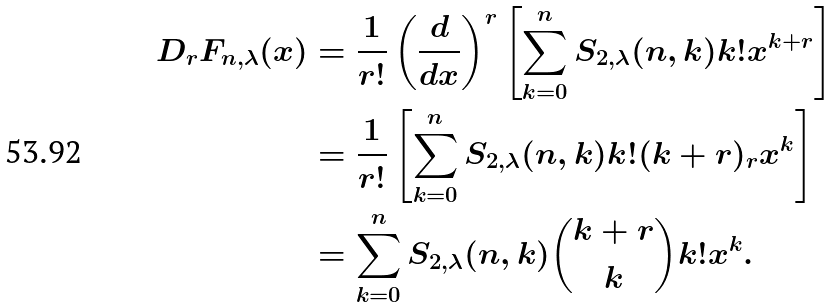<formula> <loc_0><loc_0><loc_500><loc_500>D _ { r } F _ { n , \lambda } ( x ) & = \frac { 1 } { r ! } \left ( \frac { d } { d x } \right ) ^ { r } \left [ \sum _ { k = 0 } ^ { n } S _ { 2 , \lambda } ( n , k ) k ! x ^ { k + r } \right ] \\ & = \frac { 1 } { r ! } \left [ \sum _ { k = 0 } ^ { n } S _ { 2 , \lambda } ( n , k ) k ! ( k + r ) _ { r } x ^ { k } \right ] \\ & = \sum _ { k = 0 } ^ { n } S _ { 2 , \lambda } ( n , k ) \binom { k + r } { k } k ! x ^ { k } .</formula> 